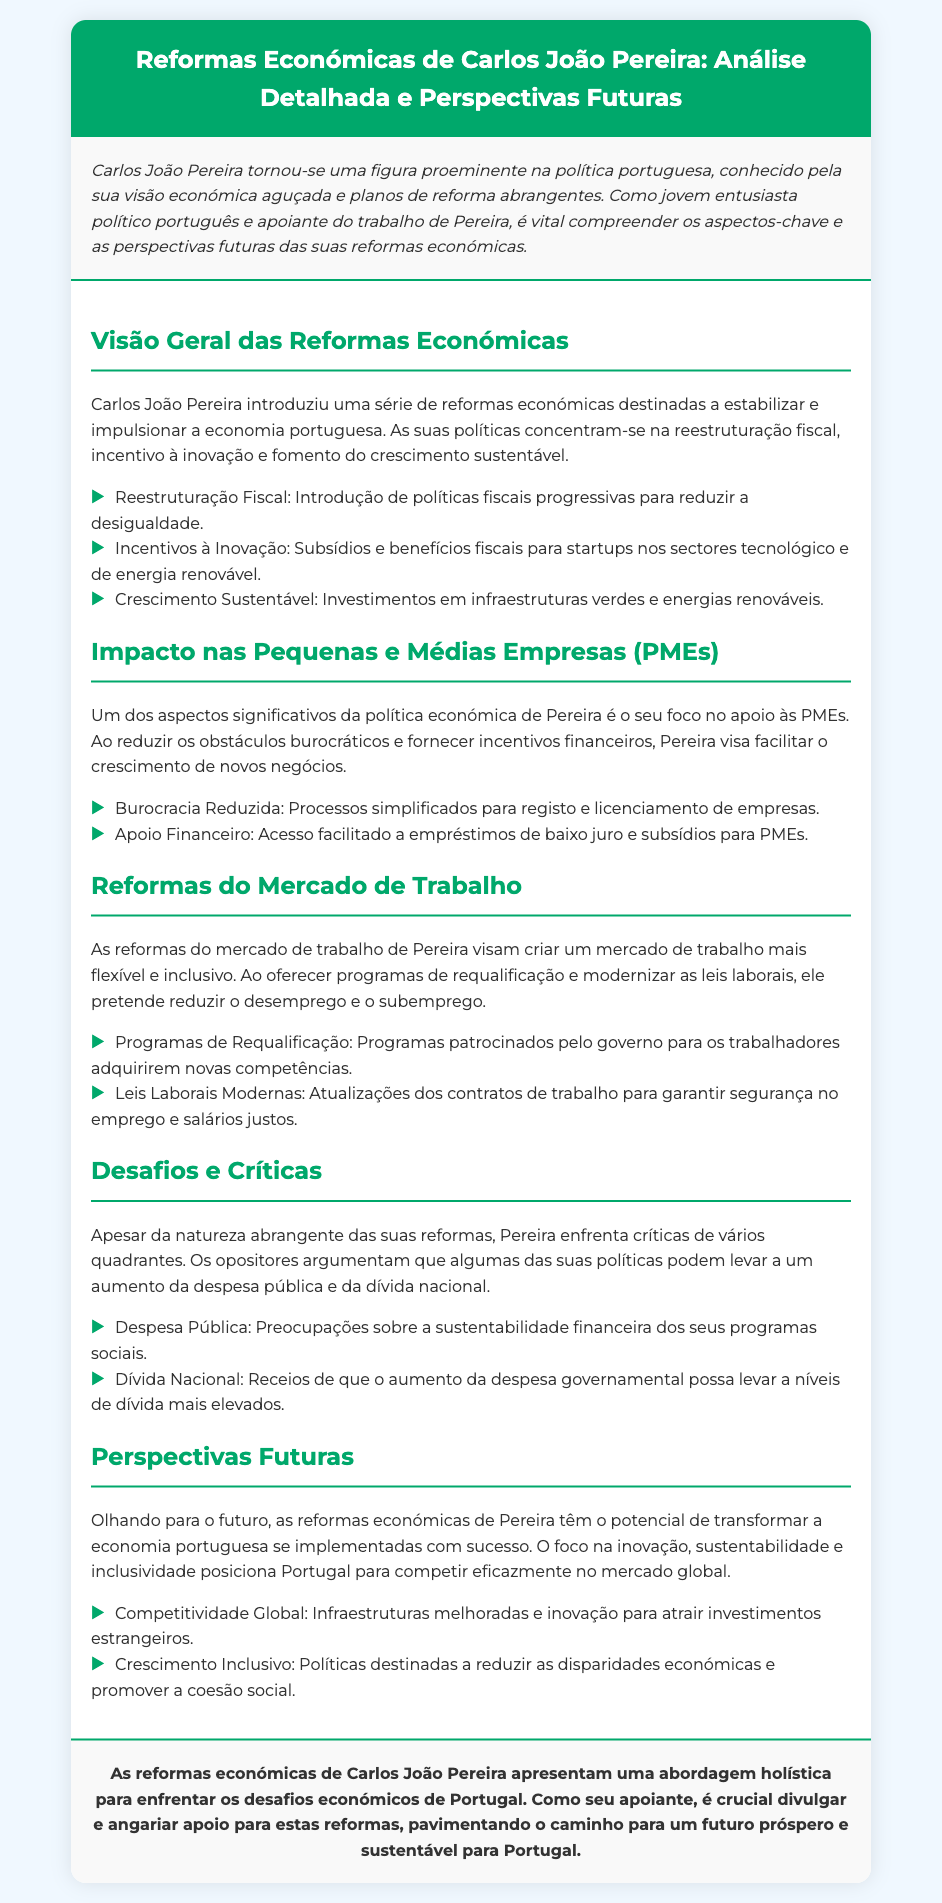what is the main focus of Carlos João Pereira's economic reforms? The main focus of Pereira's economic reforms includes restructuring fiscal policies, encouraging innovation, and promoting sustainable growth.
Answer: reestruturação fiscal, incentivo à inovação, crescimento sustentável what types of support does Pereira provide for small and medium enterprises (PMEs)? Pereira supports PMEs by reducing bureaucratic obstacles and providing financial incentives.
Answer: reduzindo obstáculos burocráticos e fornecendo incentivos financeiros what is one key aspect of the labor market reforms proposed by Pereira? A key aspect of the labor market reforms is the introduction of requalification programs for workers.
Answer: Programas de Requalificação what are the concerns critics have regarding Pereira's reforms? Critics are concerned about the potential increase in public spending and national debt due to Pereira's policies.
Answer: aumento da despesa pública e da dívida nacional what could the future impact of Pereira's economic reforms be? If implemented successfully, Pereira's reforms could lead to increased global competitiveness for Portugal.
Answer: competitividade global how does Pereira aim to support innovation in the economy? Pereira aims to support innovation by providing subsidies and tax benefits for startups in technology and renewable energy.
Answer: Subsídios e benefícios fiscais para startups what are the primary goals of Pereira's economic reforms? The primary goals are to stabilize and boost the Portuguese economy and reduce inequality.
Answer: estabilizar e impulsionar a economia portuguesa, reduzir a desigualdade how is the document structured? The document includes sections such as an introduction, content with various headings, and a conclusion.
Answer: introdução, várias seções no conteúdo, conclusão 